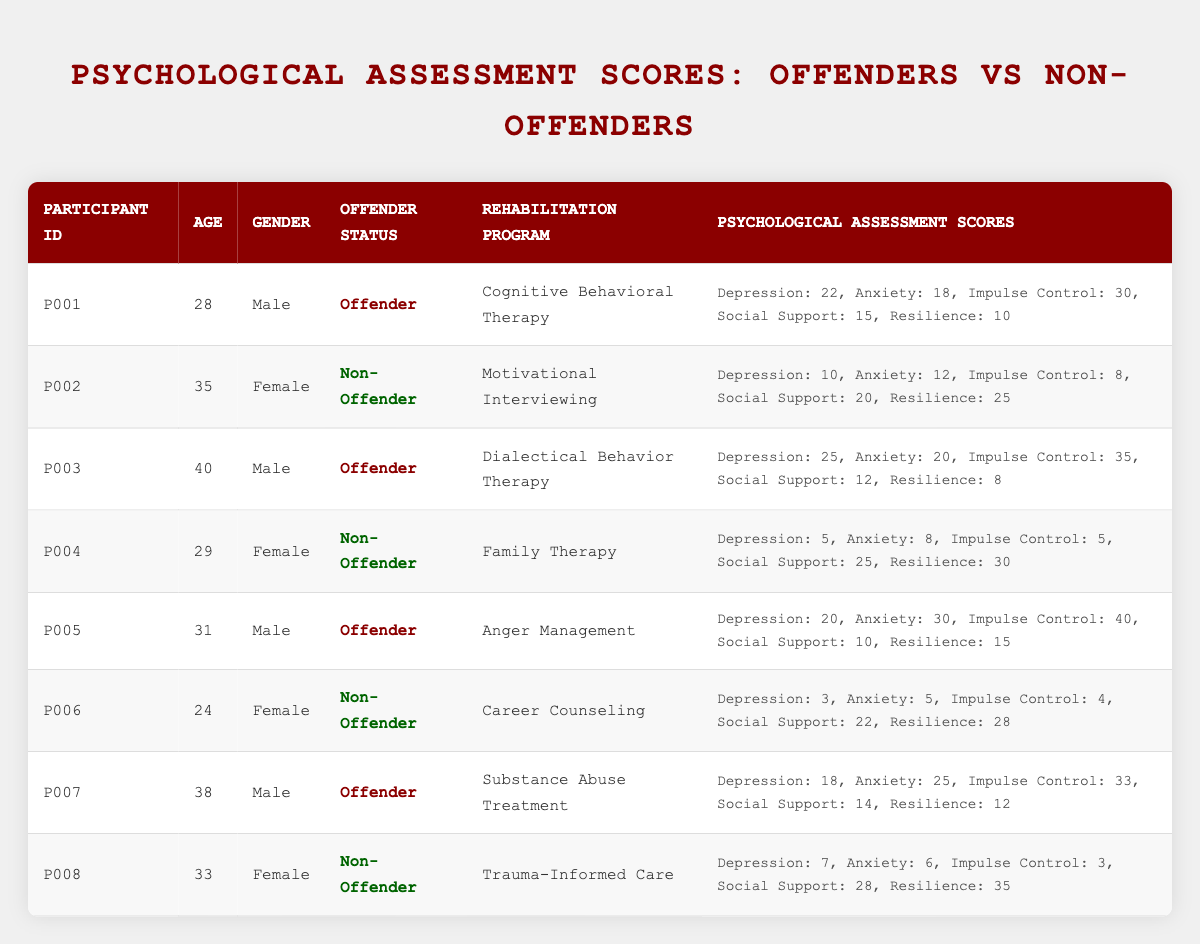What is the Psychological Assessment Score for Impulse Control for Participant P001? The score for Impulse Control is listed in the table under the Psychological Assessment Scores column for Participant P001. It shows an Impulse Control score of 30.
Answer: 30 What is the average age of offenders in this table? The ages of offenders are 28 (P001), 40 (P003), 31 (P005), and 38 (P007). Adding these ages gives 28 + 40 + 31 + 38 = 137. There are 4 offenders, so the average age is 137/4 = 34.25.
Answer: 34.25 Is Participant P006 an offender? Looking at the Offender Status column for Participant P006, it states that the status is "Non-Offender". Thus, the answer is no.
Answer: No Which rehabilitation program has the highest Psychological Assessment score for Resilience among non-offenders? The non-offender participants and their Resilience scores are: P002 (25), P004 (30), P006 (28), and P008 (35). The highest score among these is 35 for P008 in the program "Trauma-Informed Care".
Answer: Trauma-Informed Care What is the total score for Depression among all offenders in the table? The Depression scores for offenders are: P001 (22), P003 (25), P005 (20), and P007 (18). Summing these gives 22 + 25 + 20 + 18 = 85.
Answer: 85 What is the ratio of males to females in the offender group? The male offenders are P001, P003, P005, and P007 (4 total) while the female offenders are none. So, the ratio is 4:0, and since there's no female offender, it is undefined.
Answer: Undefined How does the Anxiety score of Participant P005 compare to that of Participant P002? Participant P005 has an Anxiety score of 30 while Participant P002 has a score of 12. The difference is 30 - 12 = 18, indicating P005 has a higher score.
Answer: P005 has a higher Anxiety score Are there any non-offenders who have a higher Social Support score than any offender? Checking the Social Support scores, non-offenders have scores of 20 (P002), 25 (P004), 22 (P006), and 28 (P008). Offenders have scores of 15 (P001), 12 (P003), 10 (P005), and 14 (P007). The highest non-offender score of 28 (P008) is greater than all offender scores. Therefore, yes.
Answer: Yes What is the difference in the total Impulse Control scores between offenders and non-offenders? The Impulse Control scores for offenders are 30 (P001), 35 (P003), 40 (P005), and 33 (P007), totaling 30 + 35 + 40 + 33 = 138. For non-offenders, the scores are 8 (P002), 5 (P004), 4 (P006), and 3 (P008), totaling 8 + 5 + 4 + 3 = 20. The difference is 138 - 20 = 118.
Answer: 118 